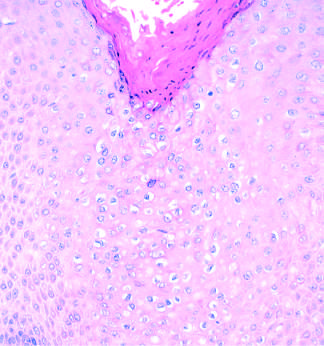what do histopathologic features of condyloma acuminatum include?
Answer the question using a single word or phrase. Acanthosis 